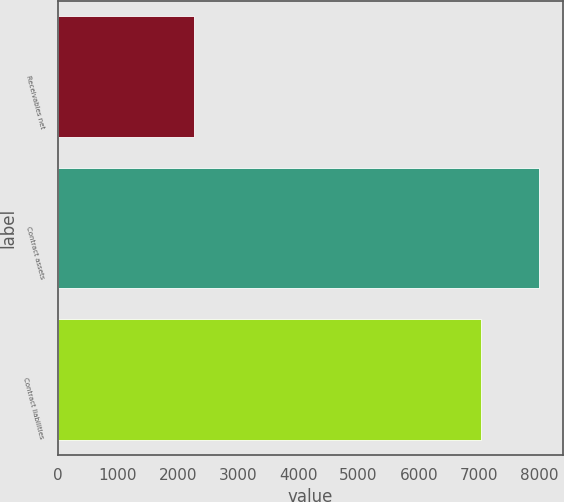Convert chart. <chart><loc_0><loc_0><loc_500><loc_500><bar_chart><fcel>Receivables net<fcel>Contract assets<fcel>Contract liabilities<nl><fcel>2265<fcel>7992<fcel>7028<nl></chart> 